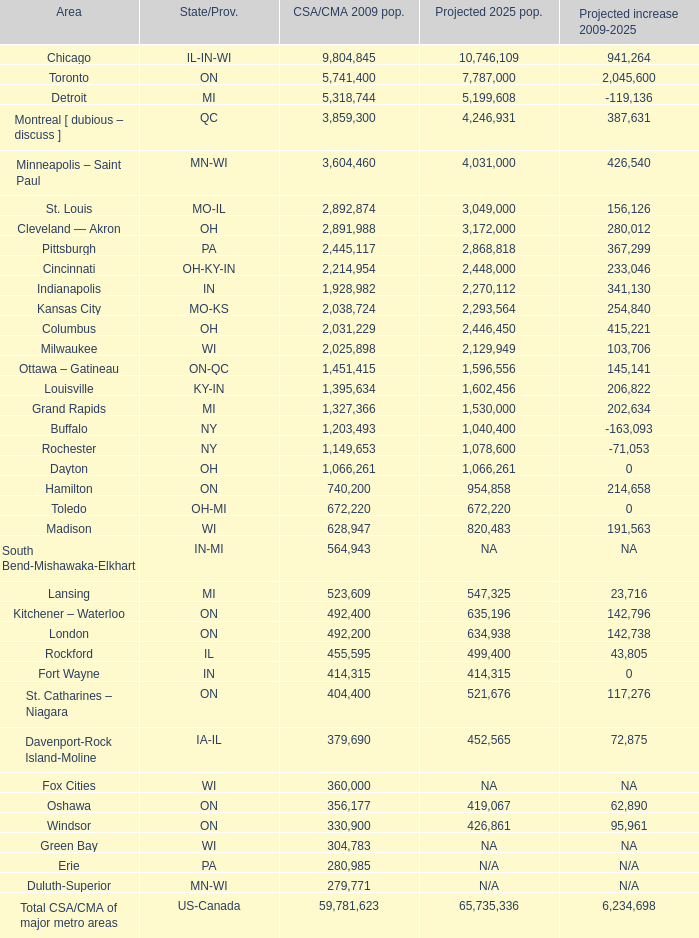What's the CSA/CMA Population in IA-IL? 379690.0. 